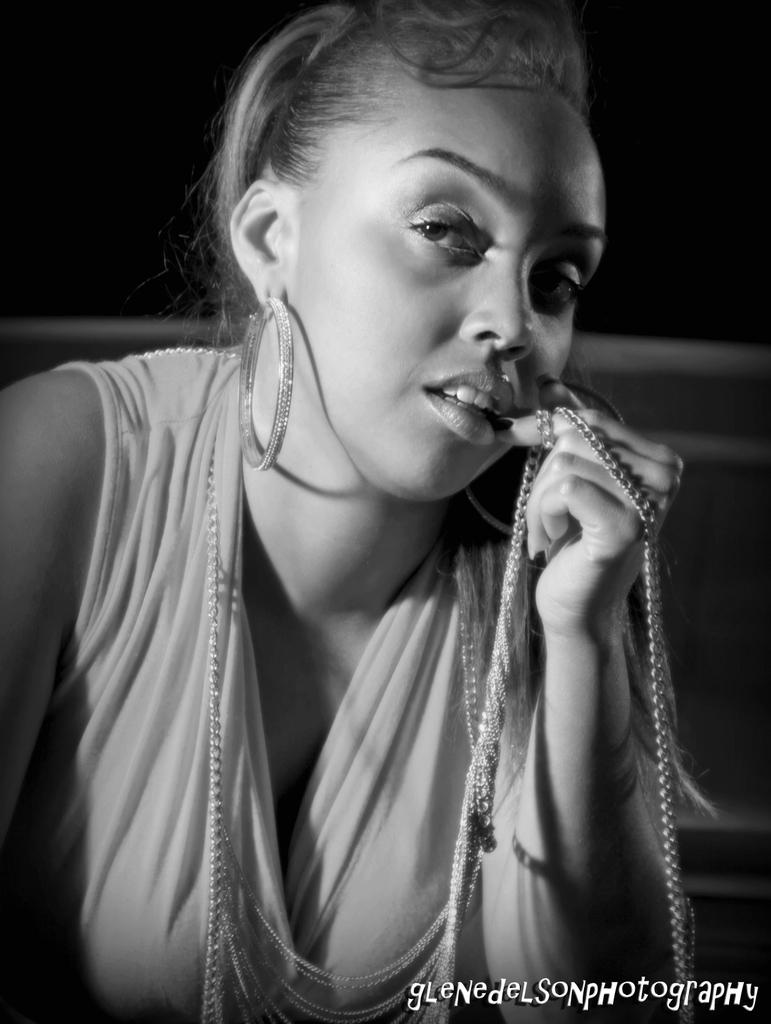What is the color scheme of the image? The image is black and white. Who is the main subject in the foreground of the image? There is a woman in the foreground of the image. What is the woman wearing or holding around her finger? The woman has a chain wrapped around her finger. How many spiders are crawling on the woman's hand in the image? There are no spiders present in the image; it only shows a woman with a chain wrapped around her finger. What type of zephyr can be seen blowing in the background of the image? There is no zephyr present in the image, as it is a black and white image with a woman and a chain wrapped around her finger. 